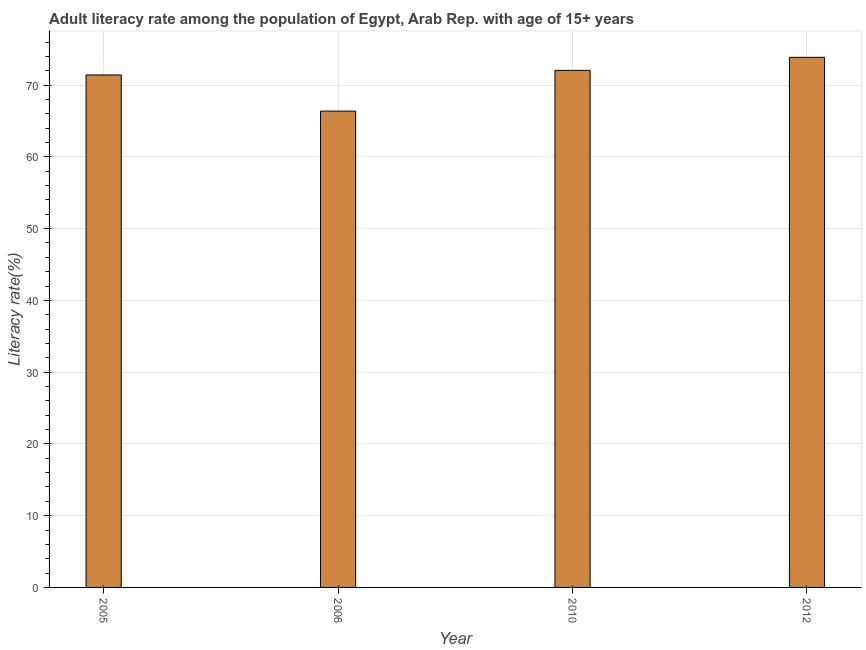What is the title of the graph?
Keep it short and to the point. Adult literacy rate among the population of Egypt, Arab Rep. with age of 15+ years. What is the label or title of the Y-axis?
Ensure brevity in your answer.  Literacy rate(%). What is the adult literacy rate in 2005?
Offer a very short reply. 71.41. Across all years, what is the maximum adult literacy rate?
Give a very brief answer. 73.87. Across all years, what is the minimum adult literacy rate?
Give a very brief answer. 66.37. In which year was the adult literacy rate maximum?
Give a very brief answer. 2012. What is the sum of the adult literacy rate?
Keep it short and to the point. 283.69. What is the difference between the adult literacy rate in 2005 and 2010?
Keep it short and to the point. -0.64. What is the average adult literacy rate per year?
Provide a short and direct response. 70.92. What is the median adult literacy rate?
Provide a short and direct response. 71.73. What is the ratio of the adult literacy rate in 2006 to that in 2012?
Offer a terse response. 0.9. Is the difference between the adult literacy rate in 2006 and 2010 greater than the difference between any two years?
Provide a succinct answer. No. What is the difference between the highest and the second highest adult literacy rate?
Ensure brevity in your answer.  1.82. How many years are there in the graph?
Your answer should be compact. 4. What is the difference between two consecutive major ticks on the Y-axis?
Offer a terse response. 10. What is the Literacy rate(%) of 2005?
Give a very brief answer. 71.41. What is the Literacy rate(%) in 2006?
Offer a very short reply. 66.37. What is the Literacy rate(%) of 2010?
Provide a short and direct response. 72.05. What is the Literacy rate(%) of 2012?
Your answer should be very brief. 73.87. What is the difference between the Literacy rate(%) in 2005 and 2006?
Make the answer very short. 5.04. What is the difference between the Literacy rate(%) in 2005 and 2010?
Your response must be concise. -0.64. What is the difference between the Literacy rate(%) in 2005 and 2012?
Give a very brief answer. -2.46. What is the difference between the Literacy rate(%) in 2006 and 2010?
Offer a terse response. -5.68. What is the difference between the Literacy rate(%) in 2006 and 2012?
Provide a short and direct response. -7.5. What is the difference between the Literacy rate(%) in 2010 and 2012?
Your response must be concise. -1.82. What is the ratio of the Literacy rate(%) in 2005 to that in 2006?
Make the answer very short. 1.08. What is the ratio of the Literacy rate(%) in 2006 to that in 2010?
Keep it short and to the point. 0.92. What is the ratio of the Literacy rate(%) in 2006 to that in 2012?
Your response must be concise. 0.9. 